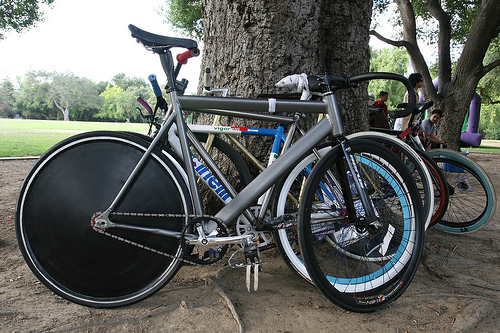<image>
Can you confirm if the bicycle is in the tree? No. The bicycle is not contained within the tree. These objects have a different spatial relationship. Is the bicycle next to the tree? Yes. The bicycle is positioned adjacent to the tree, located nearby in the same general area. Is the cycle in front of the tree? Yes. The cycle is positioned in front of the tree, appearing closer to the camera viewpoint. 